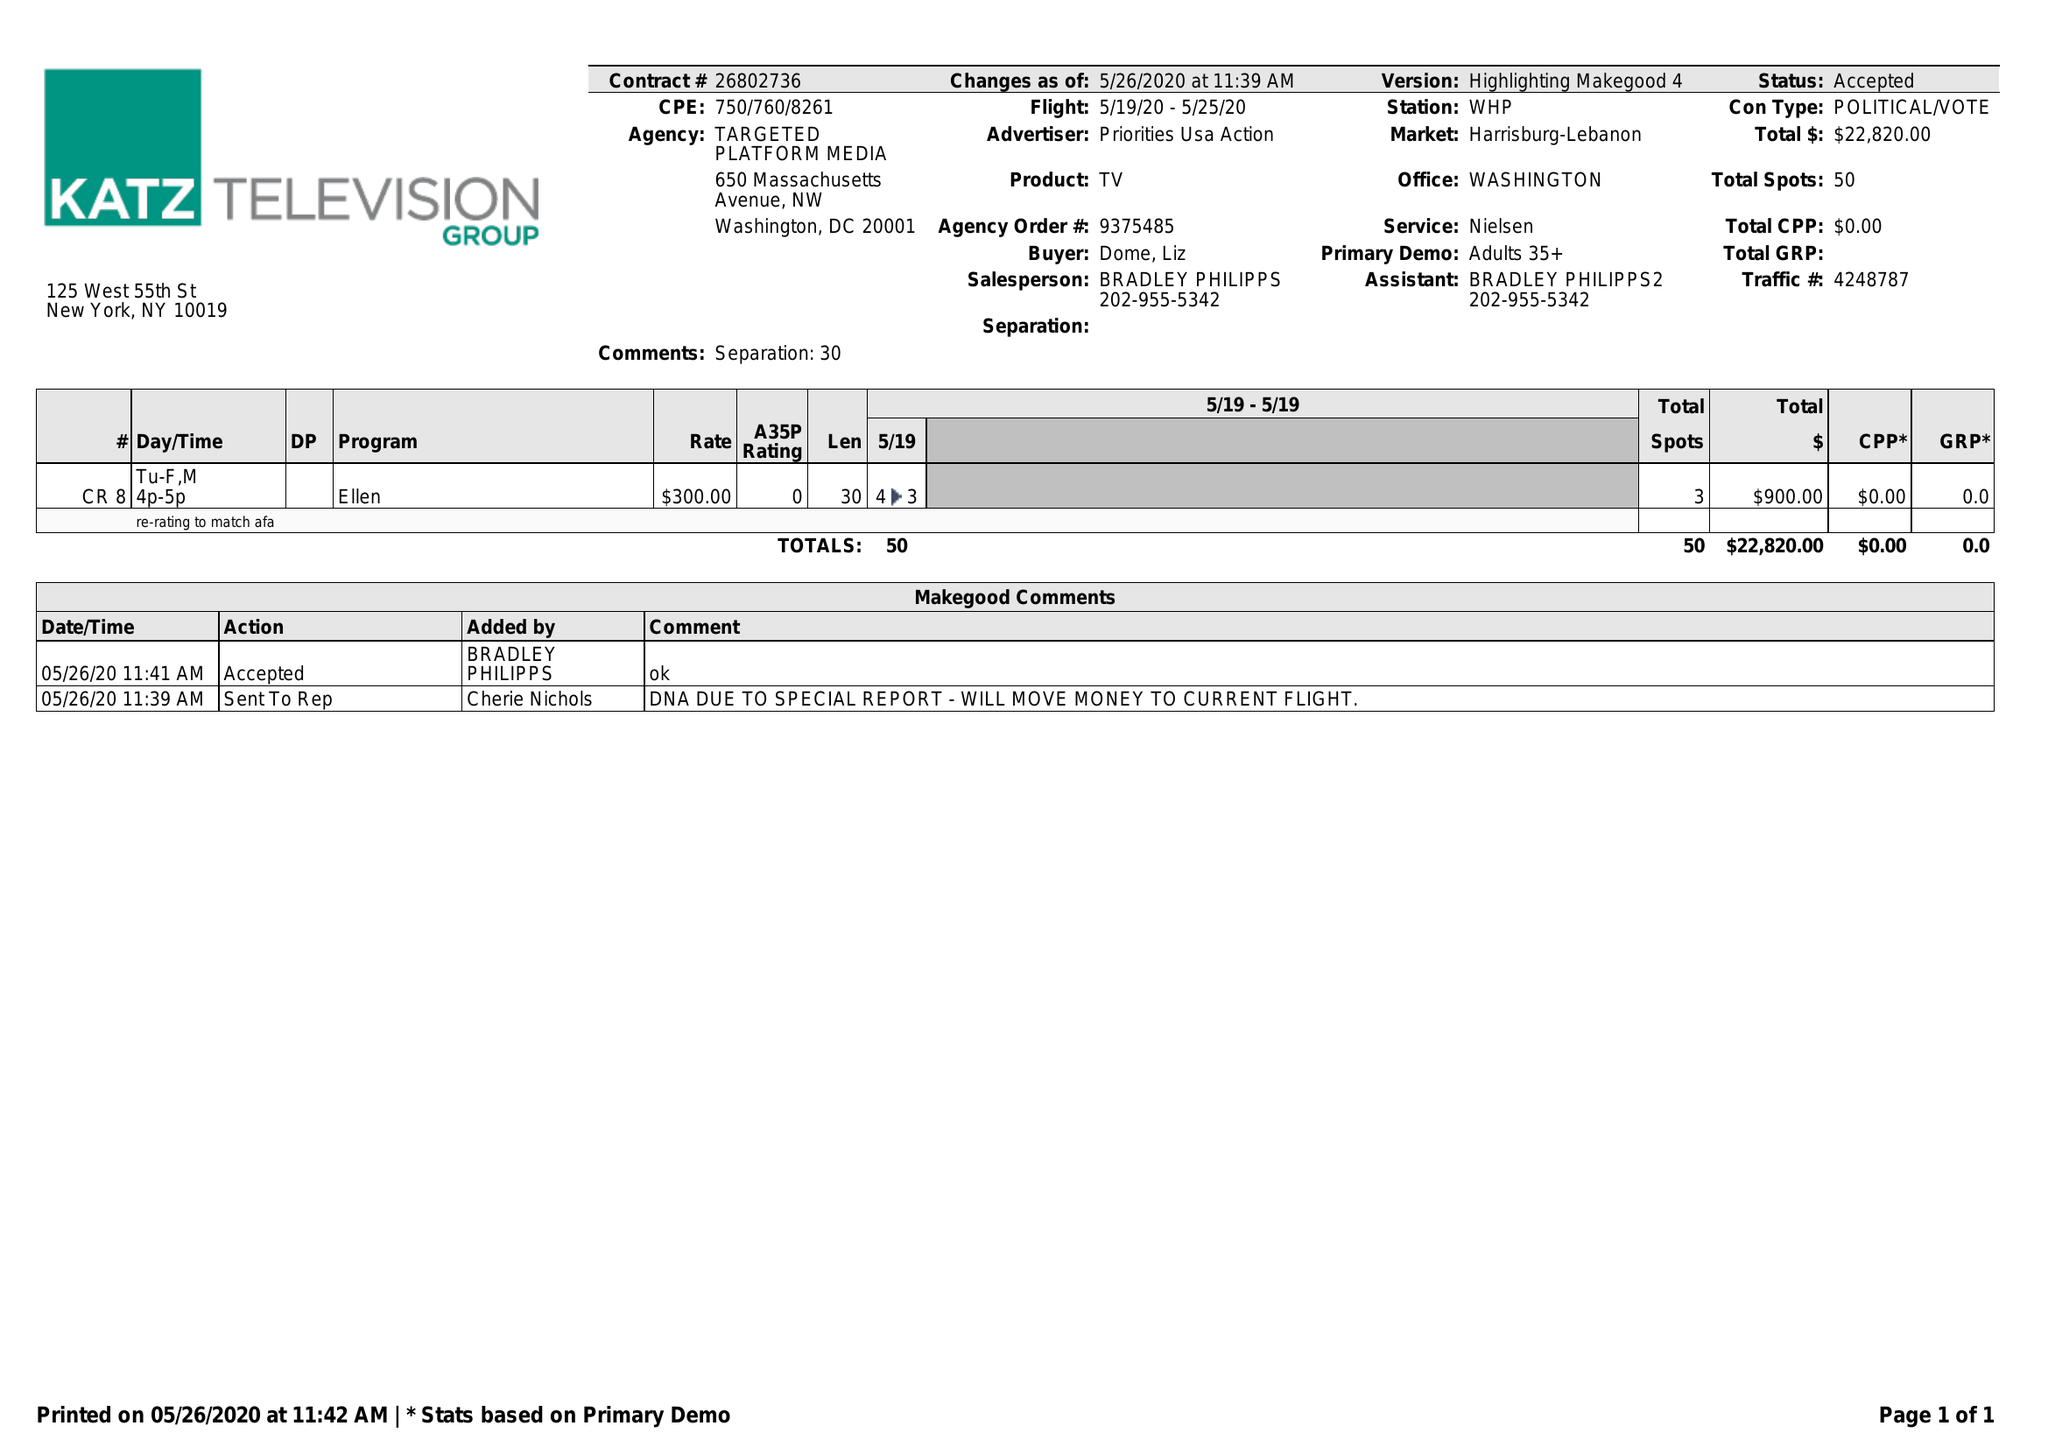What is the value for the flight_from?
Answer the question using a single word or phrase. 05/19/20 